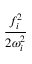Convert formula to latex. <formula><loc_0><loc_0><loc_500><loc_500>\frac { f _ { i } ^ { 2 } } { 2 \omega _ { i } ^ { 2 } }</formula> 